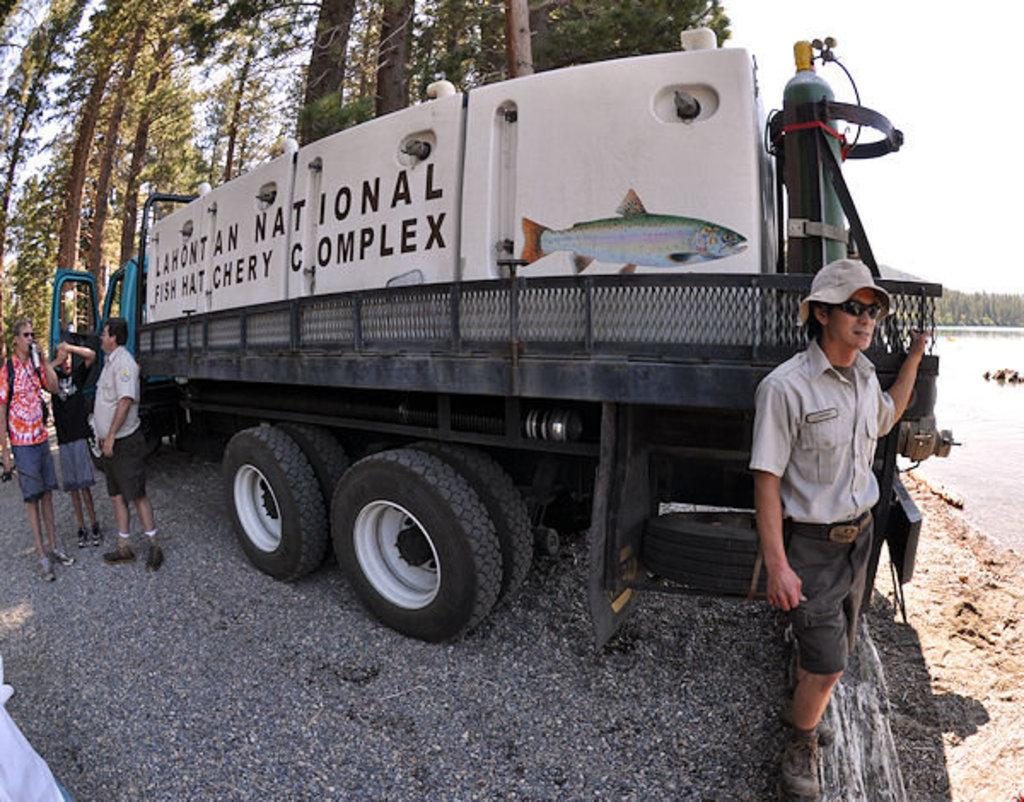What is the main subject of the image? There is a vehicle in the image. What are the people near the vehicle doing? The people are standing near the vehicle. What can be seen in the right corner of the image? There is water visible in the right corner of the image. What is visible in the background of the image? There are trees in the background of the image. What is the name of the toy that the people are playing with near the vehicle? There are no toys present in the image, and the people are not playing with any toys. 